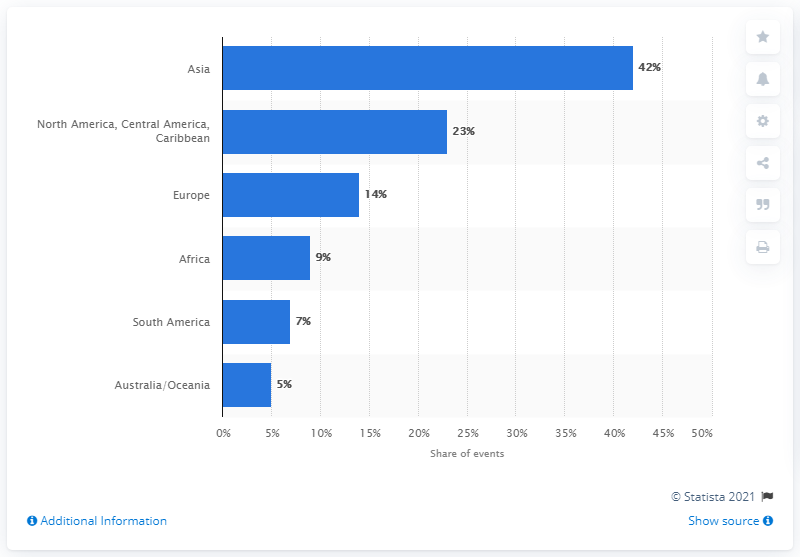Mention a couple of crucial points in this snapshot. The sum of the least three values is 21. North America has the second highest number of catastrophes, followed by Central America and the Caribbean. 